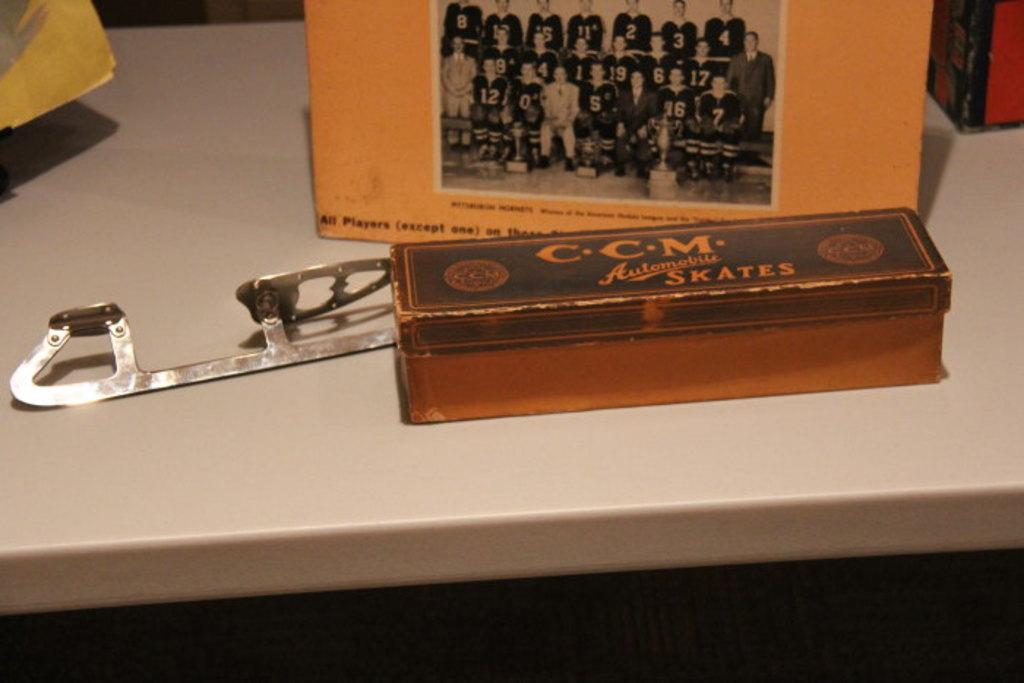<image>
Offer a succinct explanation of the picture presented. An old blade for an ice skate sits behind a box labeled .CC.M. skates. 